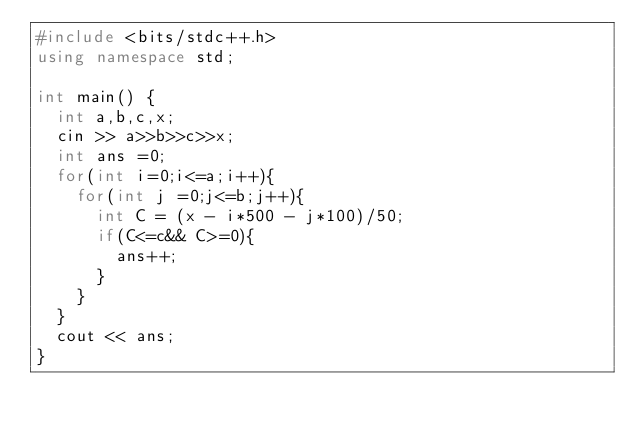Convert code to text. <code><loc_0><loc_0><loc_500><loc_500><_C++_>#include <bits/stdc++.h>
using namespace std;
 
int main() {
  int a,b,c,x;
  cin >> a>>b>>c>>x;
  int ans =0;
  for(int i=0;i<=a;i++){
    for(int j =0;j<=b;j++){
      int C = (x - i*500 - j*100)/50;
      if(C<=c&& C>=0){
        ans++;
      }
    }
  }
  cout << ans;
}</code> 